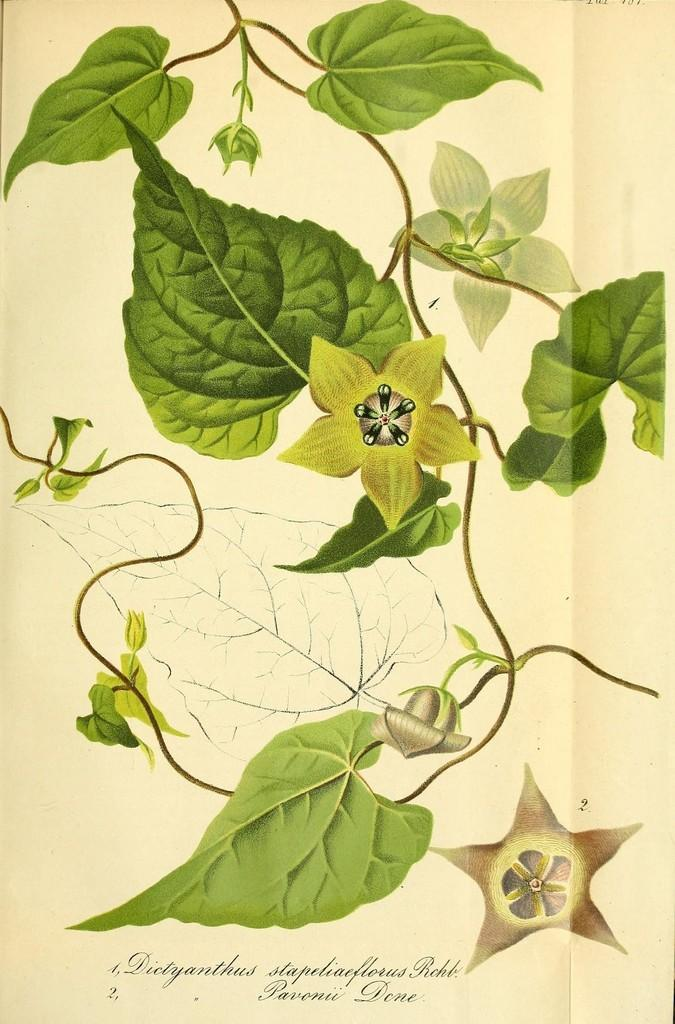What is the main subject of the image? The main subject of the image is a paper. What is depicted on the paper? The paper has leaves and flowers depicted on it. Is there any text present in the image? Yes, there is text at the bottom of the image. What type of shoe is depicted on the paper in the image? There is no shoe depicted on the paper in the image; it features leaves and flowers. 